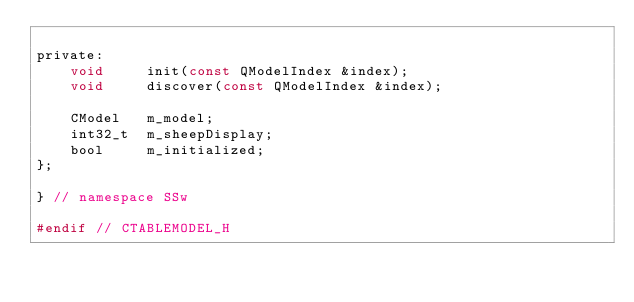<code> <loc_0><loc_0><loc_500><loc_500><_C_>
private:
    void     init(const QModelIndex &index);
    void     discover(const QModelIndex &index);

    CModel   m_model;
    int32_t  m_sheepDisplay;
    bool     m_initialized;
};

} // namespace SSw

#endif // CTABLEMODEL_H
</code> 